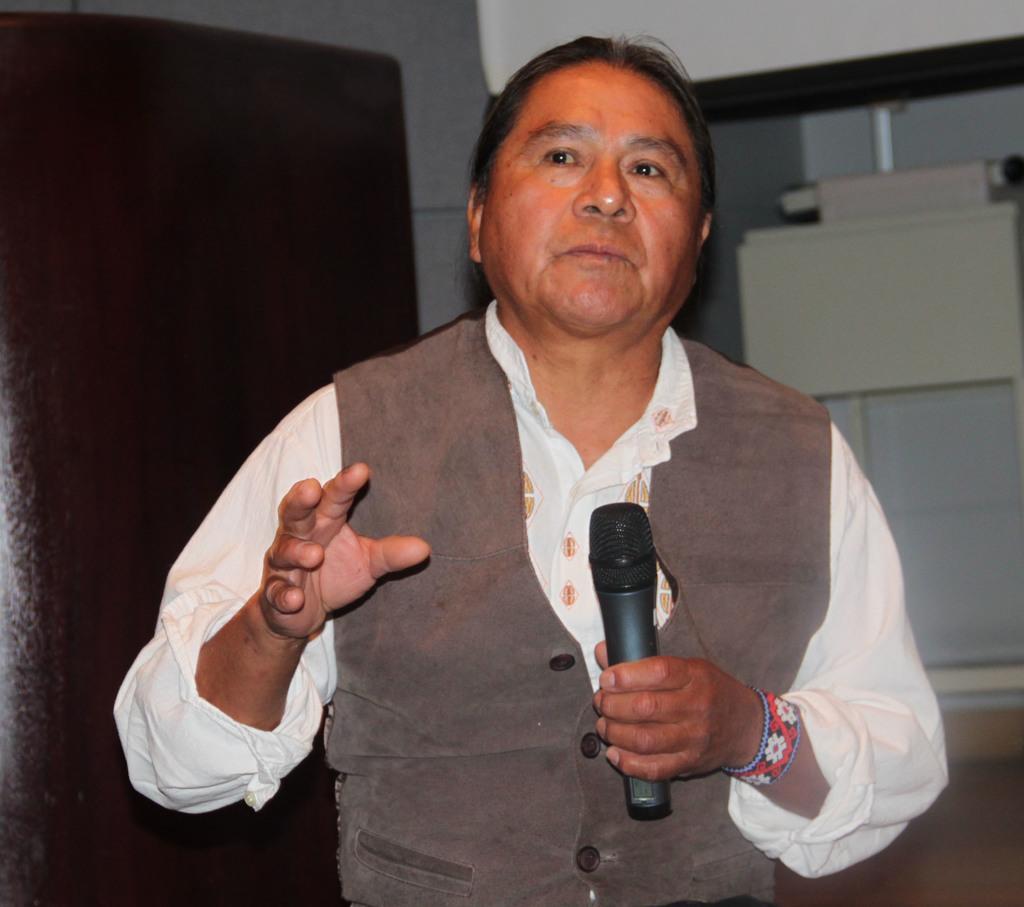Please provide a concise description of this image. In this picture we can see man wore jacket holding mic in his hand and in the background we can see door, wall, window. 